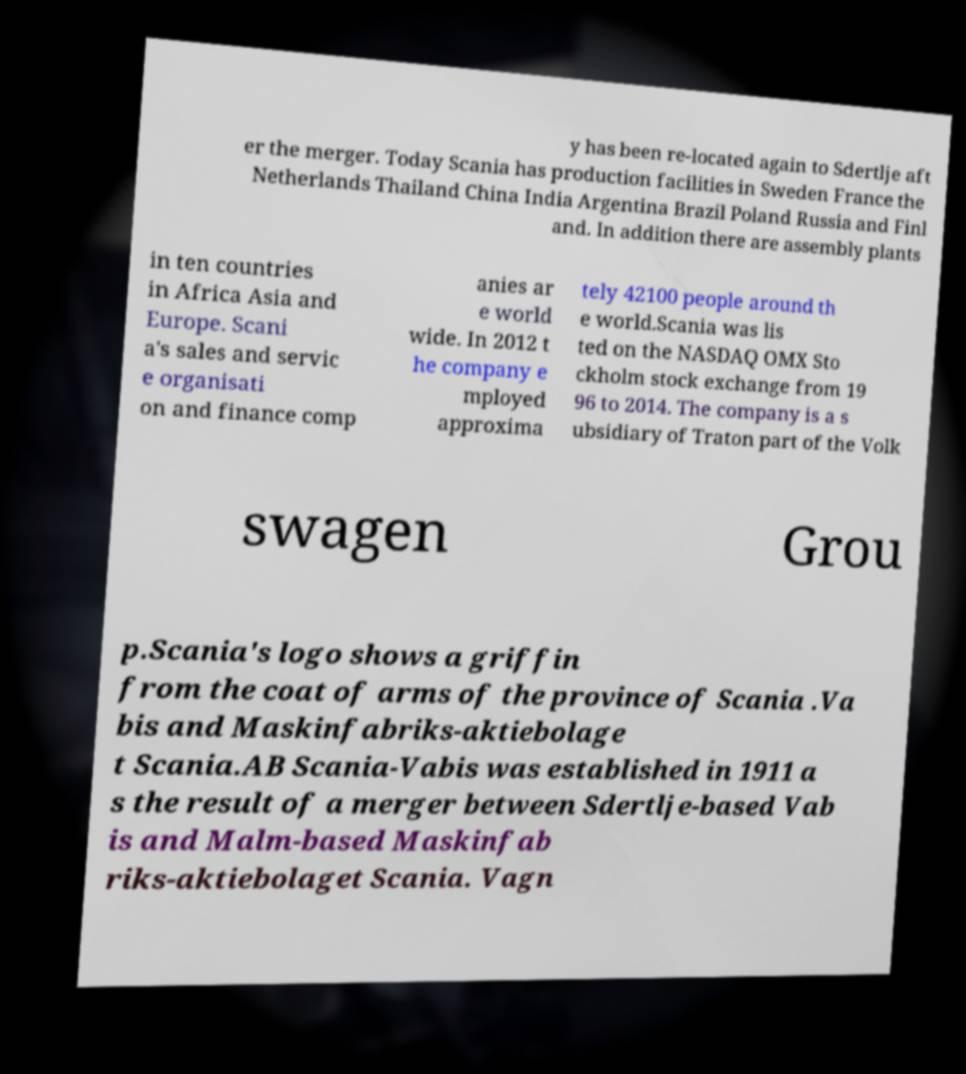Could you assist in decoding the text presented in this image and type it out clearly? y has been re-located again to Sdertlje aft er the merger. Today Scania has production facilities in Sweden France the Netherlands Thailand China India Argentina Brazil Poland Russia and Finl and. In addition there are assembly plants in ten countries in Africa Asia and Europe. Scani a's sales and servic e organisati on and finance comp anies ar e world wide. In 2012 t he company e mployed approxima tely 42100 people around th e world.Scania was lis ted on the NASDAQ OMX Sto ckholm stock exchange from 19 96 to 2014. The company is a s ubsidiary of Traton part of the Volk swagen Grou p.Scania's logo shows a griffin from the coat of arms of the province of Scania .Va bis and Maskinfabriks-aktiebolage t Scania.AB Scania-Vabis was established in 1911 a s the result of a merger between Sdertlje-based Vab is and Malm-based Maskinfab riks-aktiebolaget Scania. Vagn 